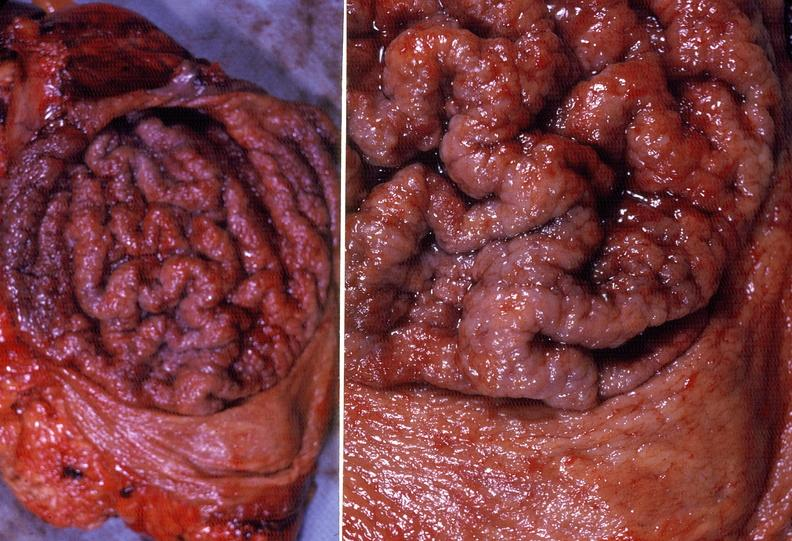s simian crease present?
Answer the question using a single word or phrase. No 